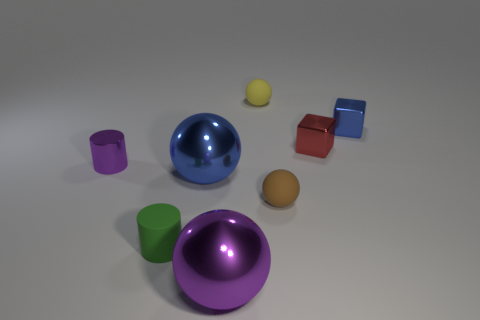What number of other things are there of the same color as the matte cylinder? Upon examining the image, there appears to be one large sphere and one small cylinder that share the same striking purple hue as the matte cylinder, resulting in a total of two items of a similar color. 